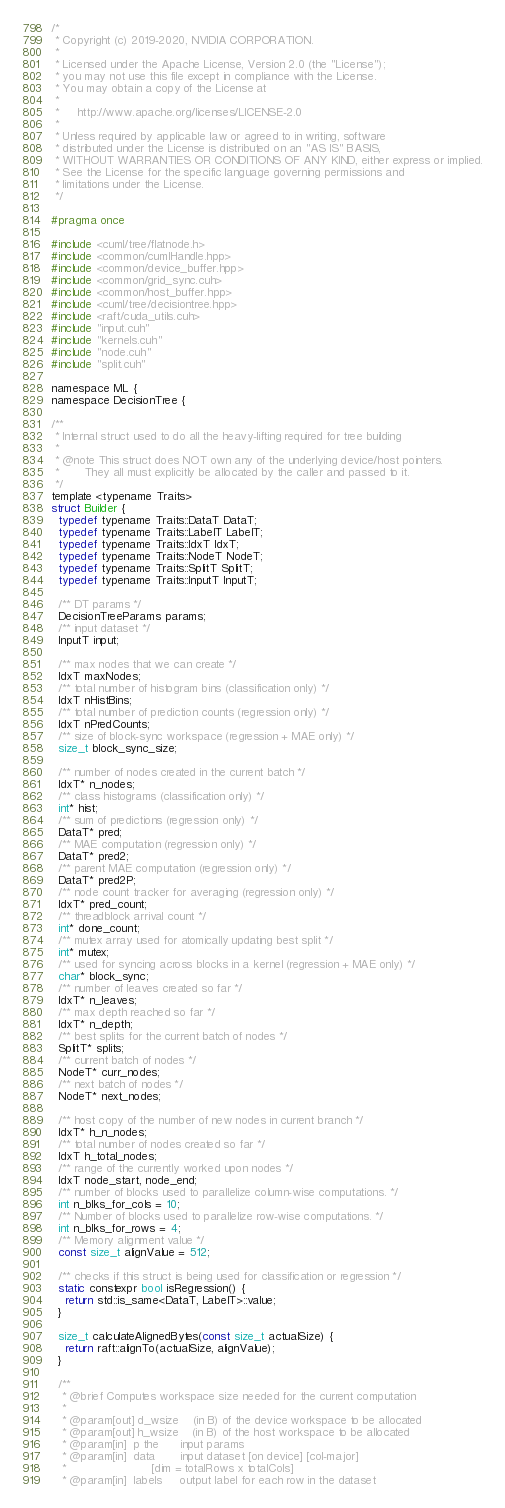<code> <loc_0><loc_0><loc_500><loc_500><_Cuda_>/*
 * Copyright (c) 2019-2020, NVIDIA CORPORATION.
 *
 * Licensed under the Apache License, Version 2.0 (the "License");
 * you may not use this file except in compliance with the License.
 * You may obtain a copy of the License at
 *
 *     http://www.apache.org/licenses/LICENSE-2.0
 *
 * Unless required by applicable law or agreed to in writing, software
 * distributed under the License is distributed on an "AS IS" BASIS,
 * WITHOUT WARRANTIES OR CONDITIONS OF ANY KIND, either express or implied.
 * See the License for the specific language governing permissions and
 * limitations under the License.
 */

#pragma once

#include <cuml/tree/flatnode.h>
#include <common/cumlHandle.hpp>
#include <common/device_buffer.hpp>
#include <common/grid_sync.cuh>
#include <common/host_buffer.hpp>
#include <cuml/tree/decisiontree.hpp>
#include <raft/cuda_utils.cuh>
#include "input.cuh"
#include "kernels.cuh"
#include "node.cuh"
#include "split.cuh"

namespace ML {
namespace DecisionTree {

/**
 * Internal struct used to do all the heavy-lifting required for tree building
 *
 * @note This struct does NOT own any of the underlying device/host pointers.
 *       They all must explicitly be allocated by the caller and passed to it.
 */
template <typename Traits>
struct Builder {
  typedef typename Traits::DataT DataT;
  typedef typename Traits::LabelT LabelT;
  typedef typename Traits::IdxT IdxT;
  typedef typename Traits::NodeT NodeT;
  typedef typename Traits::SplitT SplitT;
  typedef typename Traits::InputT InputT;

  /** DT params */
  DecisionTreeParams params;
  /** input dataset */
  InputT input;

  /** max nodes that we can create */
  IdxT maxNodes;
  /** total number of histogram bins (classification only) */
  IdxT nHistBins;
  /** total number of prediction counts (regression only) */
  IdxT nPredCounts;
  /** size of block-sync workspace (regression + MAE only) */
  size_t block_sync_size;

  /** number of nodes created in the current batch */
  IdxT* n_nodes;
  /** class histograms (classification only) */
  int* hist;
  /** sum of predictions (regression only) */
  DataT* pred;
  /** MAE computation (regression only) */
  DataT* pred2;
  /** parent MAE computation (regression only) */
  DataT* pred2P;
  /** node count tracker for averaging (regression only) */
  IdxT* pred_count;
  /** threadblock arrival count */
  int* done_count;
  /** mutex array used for atomically updating best split */
  int* mutex;
  /** used for syncing across blocks in a kernel (regression + MAE only) */
  char* block_sync;
  /** number of leaves created so far */
  IdxT* n_leaves;
  /** max depth reached so far */
  IdxT* n_depth;
  /** best splits for the current batch of nodes */
  SplitT* splits;
  /** current batch of nodes */
  NodeT* curr_nodes;
  /** next batch of nodes */
  NodeT* next_nodes;

  /** host copy of the number of new nodes in current branch */
  IdxT* h_n_nodes;
  /** total number of nodes created so far */
  IdxT h_total_nodes;
  /** range of the currently worked upon nodes */
  IdxT node_start, node_end;
  /** number of blocks used to parallelize column-wise computations. */
  int n_blks_for_cols = 10;
  /** Number of blocks used to parallelize row-wise computations. */
  int n_blks_for_rows = 4;
  /** Memory alignment value */
  const size_t alignValue = 512;

  /** checks if this struct is being used for classification or regression */
  static constexpr bool isRegression() {
    return std::is_same<DataT, LabelT>::value;
  }

  size_t calculateAlignedBytes(const size_t actualSize) {
    return raft::alignTo(actualSize, alignValue);
  }

  /**
   * @brief Computes workspace size needed for the current computation
   *
   * @param[out] d_wsize    (in B) of the device workspace to be allocated
   * @param[out] h_wsize    (in B) of the host workspace to be allocated
   * @param[in]  p the      input params
   * @param[in]  data       input dataset [on device] [col-major]
   *                        [dim = totalRows x totalCols]
   * @param[in]  labels     output label for each row in the dataset</code> 